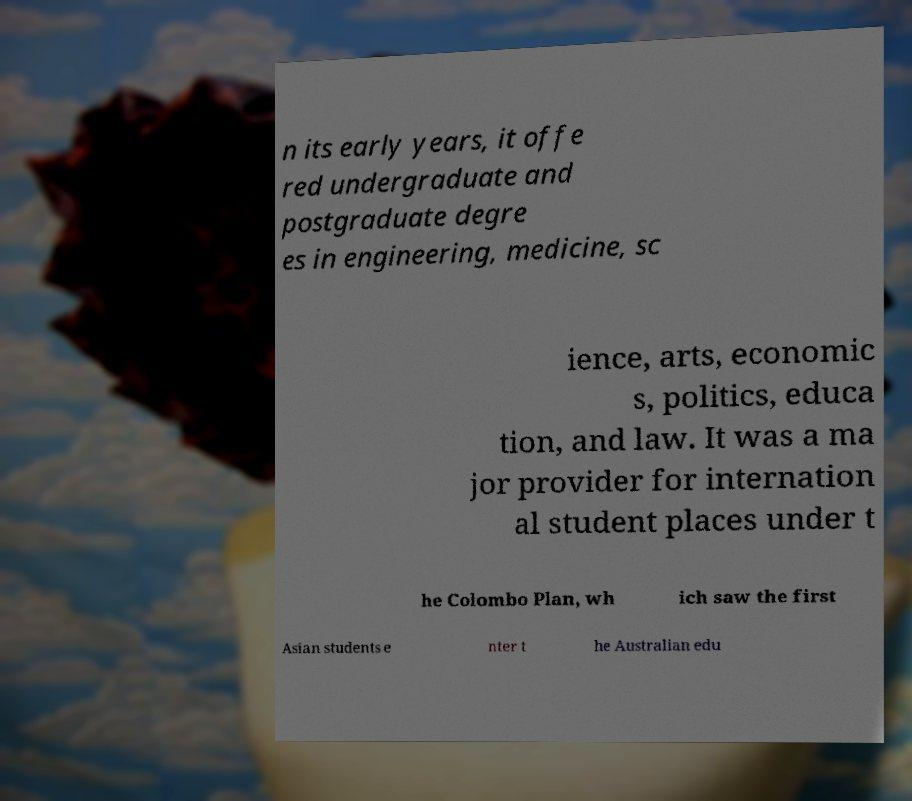Can you accurately transcribe the text from the provided image for me? n its early years, it offe red undergraduate and postgraduate degre es in engineering, medicine, sc ience, arts, economic s, politics, educa tion, and law. It was a ma jor provider for internation al student places under t he Colombo Plan, wh ich saw the first Asian students e nter t he Australian edu 